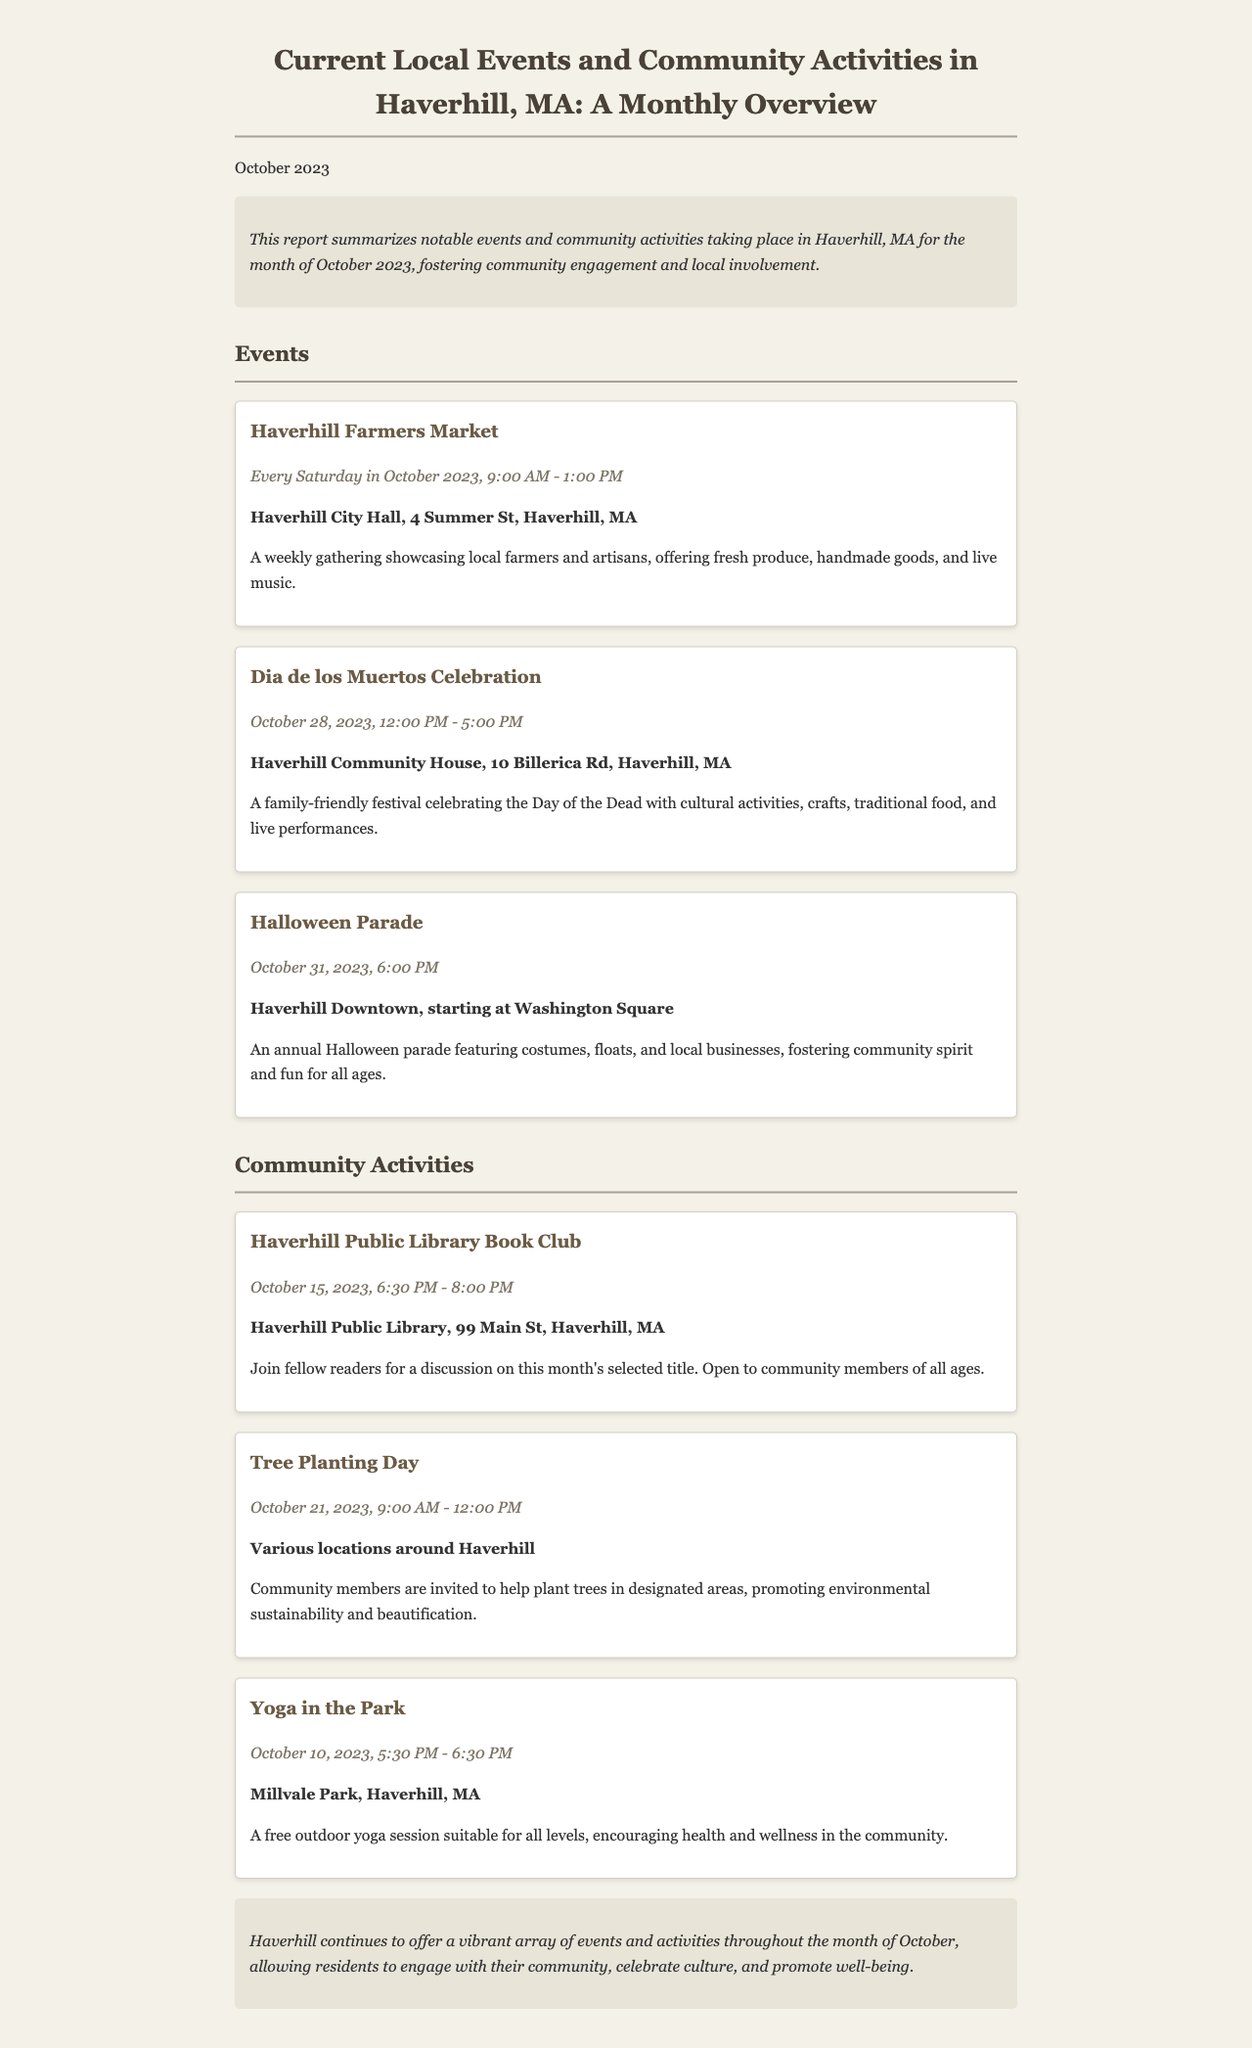what is the date range for the Haverhill Farmers Market? The document states that the Haverhill Farmers Market occurs every Saturday in October 2023, indicating a date range from October 1 to October 31, 2023.
Answer: October 1 to October 31, 2023 where is the Dia de los Muertos Celebration held? The location for the Dia de los Muertos Celebration is provided in the document, which specifies Haverhill Community House, 10 Billerica Rd, Haverhill, MA.
Answer: Haverhill Community House, 10 Billerica Rd, Haverhill, MA when is the Halloween Parade scheduled? The document mentions that the Halloween Parade is scheduled for October 31, 2023, at 6:00 PM.
Answer: October 31, 2023, 6:00 PM how many community activities are listed in the document? The document lists three community activities, which are the Haverhill Public Library Book Club, Tree Planting Day, and Yoga in the Park.
Answer: Three what is the main purpose of the Tree Planting Day activity? The document describes the Tree Planting Day as promoting environmental sustainability and beautification in Haverhill.
Answer: Environmental sustainability and beautification what type of events does the Haverhill Farmers Market showcase? The text mentions that the Farmers Market showcases local farmers and artisans, offering fresh produce, handmade goods, and live music.
Answer: Local farmers and artisans, fresh produce, handmade goods, and live music what is the nature of the Yoga in the Park event? The document describes Yoga in the Park as a free outdoor session suitable for all levels encouraging health and wellness in the community.
Answer: Free outdoor session suitable for all levels what style of activities can families expect at the Dia de los Muertos Celebration? The document outlines that families can expect cultural activities, crafts, traditional food, and live performances during the celebration.
Answer: Cultural activities, crafts, traditional food, and live performances 